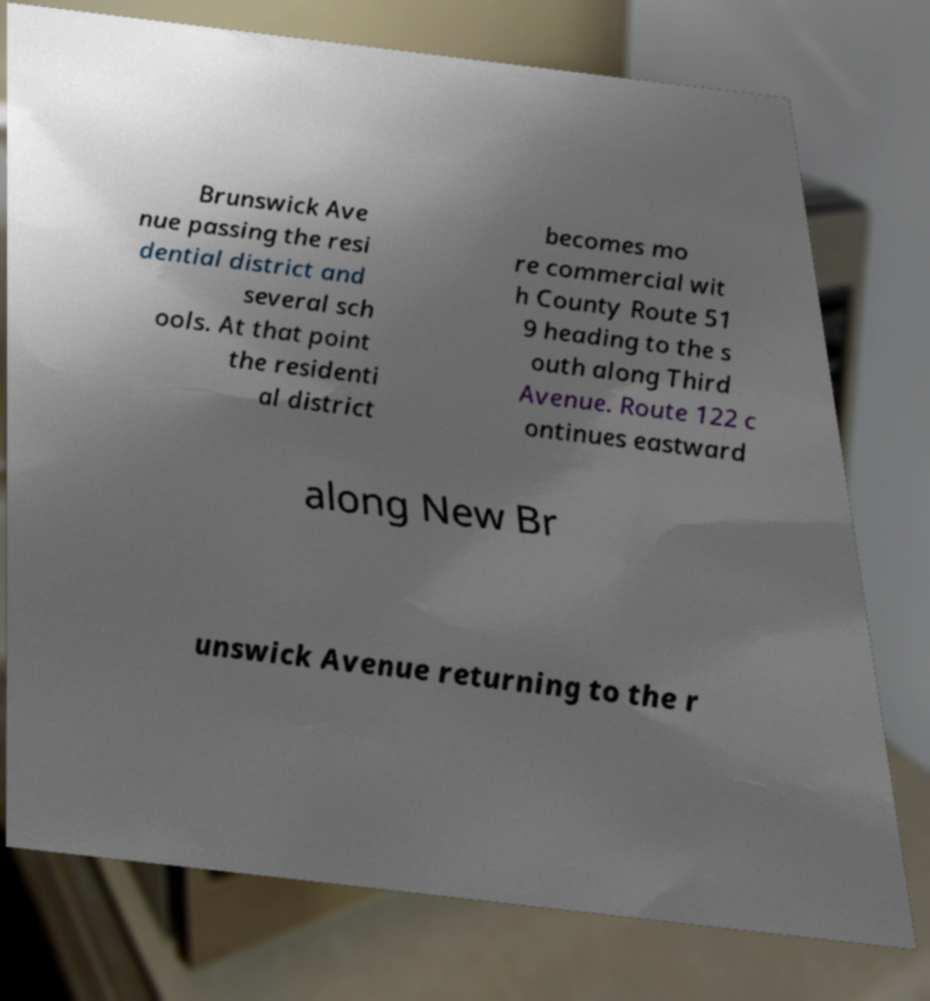Please read and relay the text visible in this image. What does it say? Brunswick Ave nue passing the resi dential district and several sch ools. At that point the residenti al district becomes mo re commercial wit h County Route 51 9 heading to the s outh along Third Avenue. Route 122 c ontinues eastward along New Br unswick Avenue returning to the r 